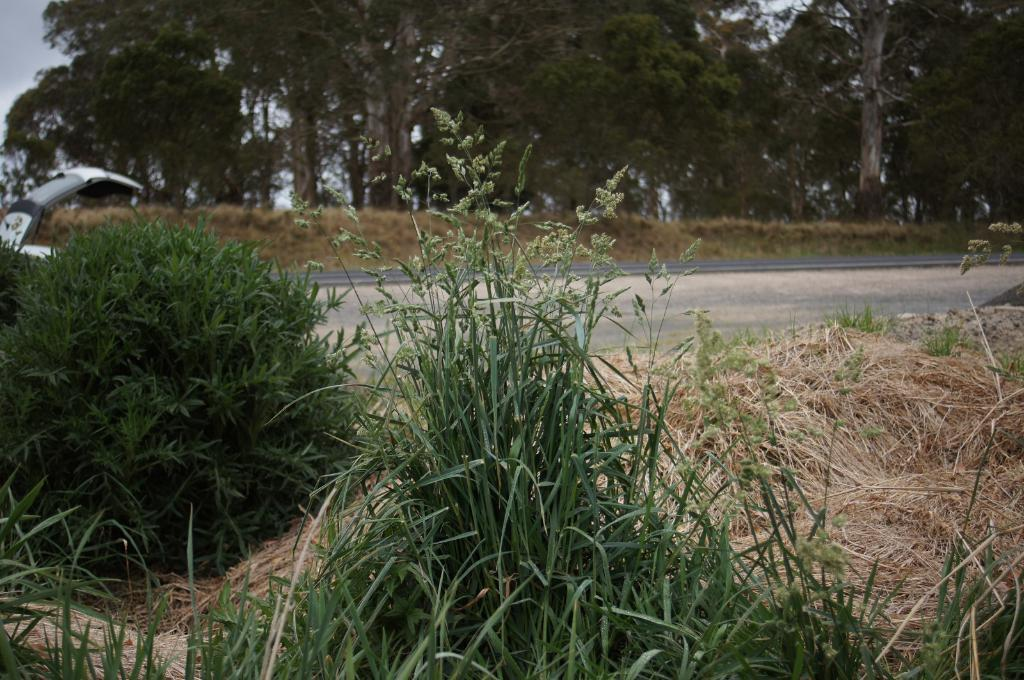What is located in the foreground of the image? There is a group of dried grass in the foreground of the image. Where is the car positioned in the image? The car is on the left side of the image. What can be seen in the background of the image? There is a group of trees and the sky visible in the background of the image. What type of oil is being used by the cat in the image? There is no cat present in the image, and therefore no oil usage can be observed. What is the yoke being used for in the image? There is no yoke present in the image, so it cannot be used for any purpose in the image. 